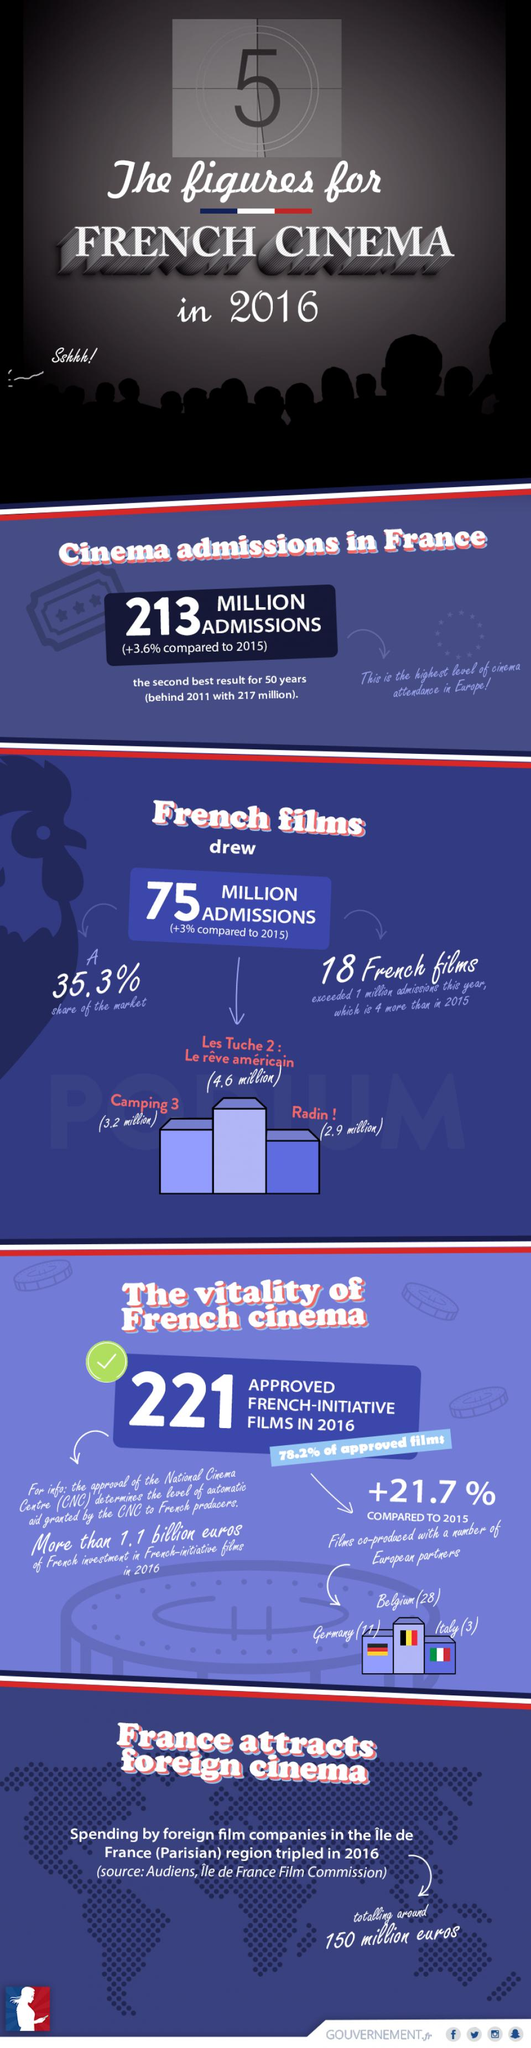Draw attention to some important aspects in this diagram. The number of admissions to the movie "Camping 3" was higher than the movie "Radin !" by 0.3 million. The number of admissions for the French movie "Camping 3" was approximately 3.2 million. The highest result for cinema admissions in France was 217 million. Fourteen French films exceeded one million admissions in the year 2015. In total, 138 million cinema admissions were for non-French films in France. 